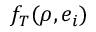Convert formula to latex. <formula><loc_0><loc_0><loc_500><loc_500>f _ { T } ( \rho , e _ { i } )</formula> 